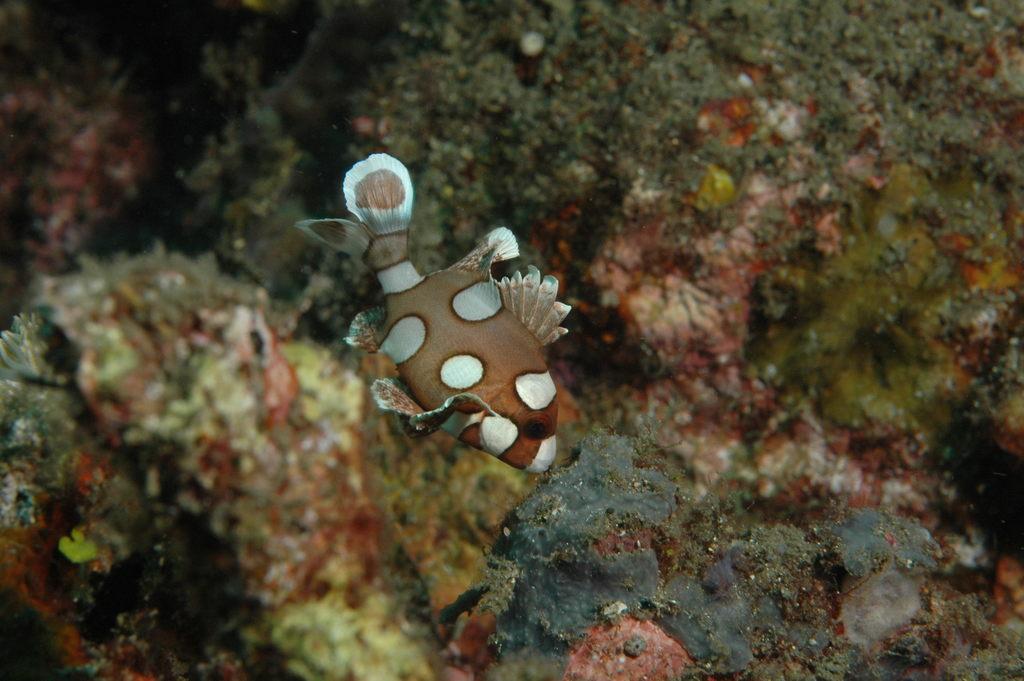In one or two sentences, can you explain what this image depicts? There is a fish in the middle of this image. We can see Sea plants in the background. 